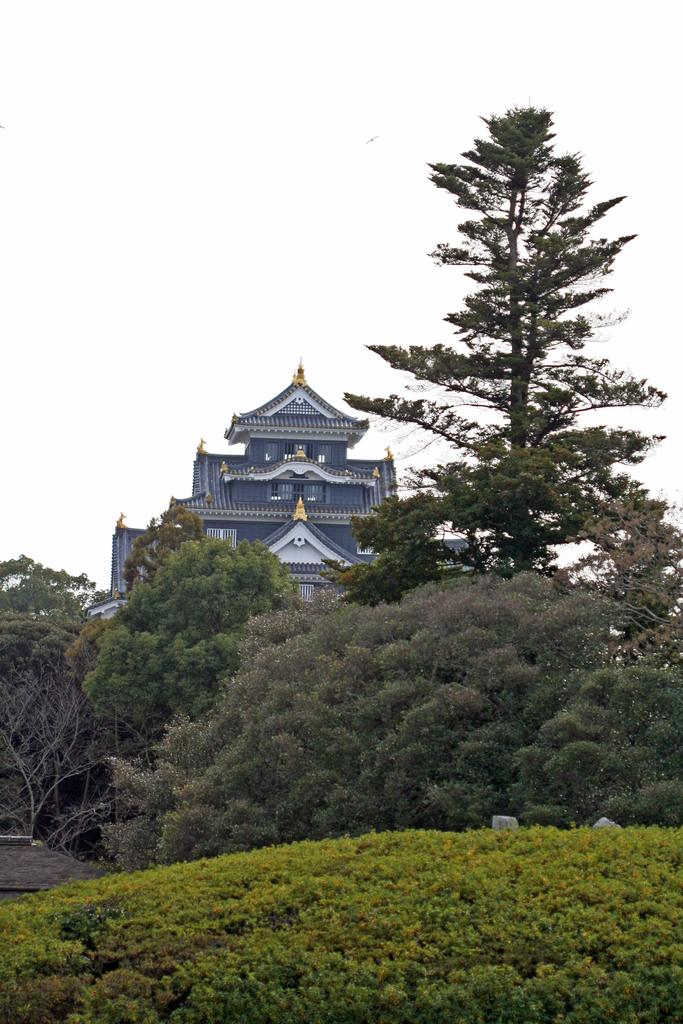What type of structure can be seen in the image? There is a building in the image. What natural elements are present in the image? There are many trees and plants in the image. What can be seen in the sky in the image? The sky is visible in the image. What is located at the left side of the image? There is an object at the left side of the image. What is the tendency of the flock of birds in the image? There are no birds or flocks present in the image, so it is not possible to determine any tendencies. 